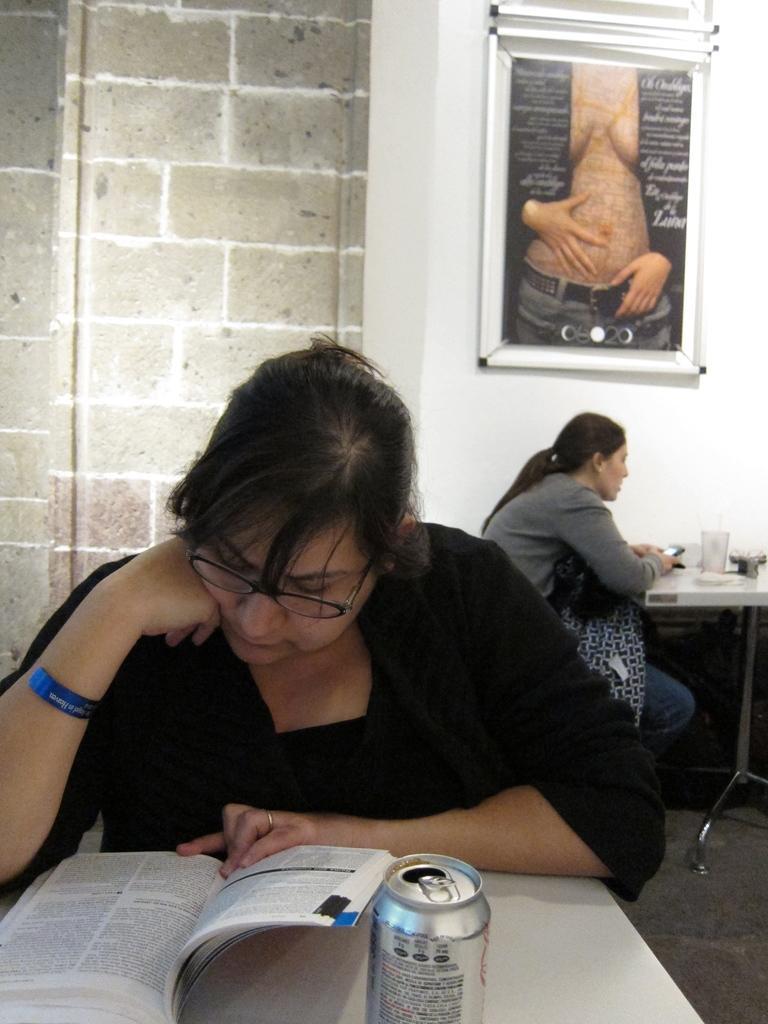Please provide a concise description of this image. In this picture, There is a table which is in white color on that table there is a book and there is a can, In the middle there is a woman sitting and she is reading a book and in the background there is a woman siting on the chair and there is a wall and poster in white color. 